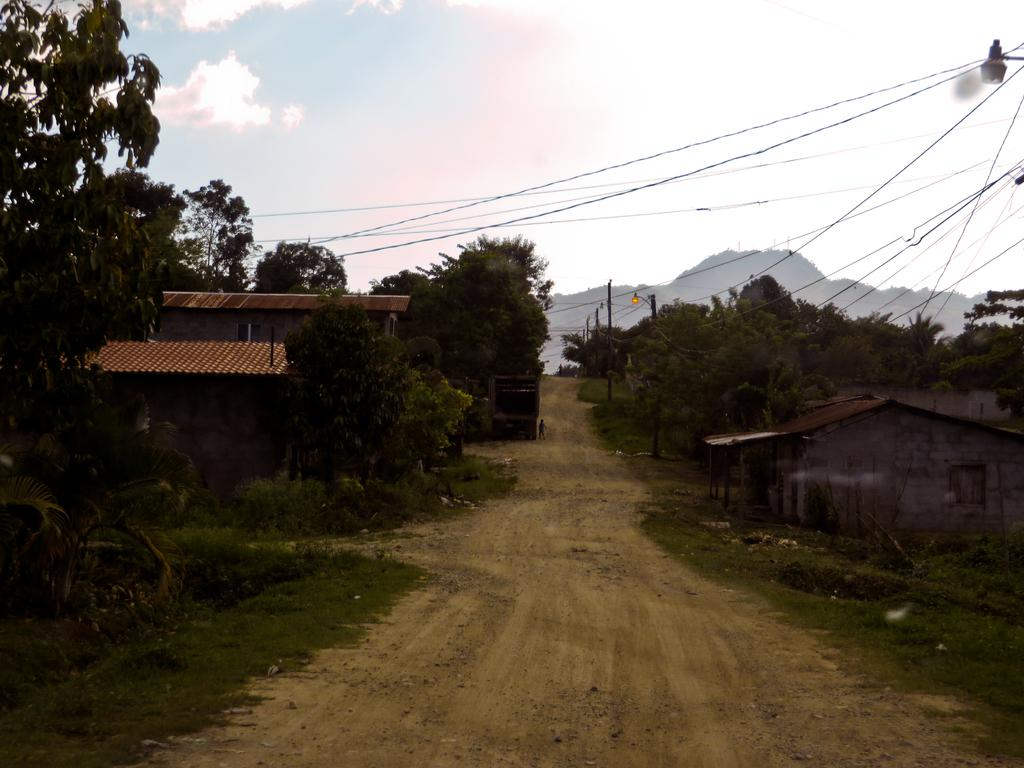What is the main feature in the center of the image? There is a dirt road in the center of the image. What can be seen on either side of the dirt road? There are trees and houses on either side of the dirt road. What else is visible in the image? There are wires visible in the image. What can be seen in the background of the image? There are mountains in the background of the image. What type of silver table can be seen in the image? There is no silver table present in the image. What beliefs are represented by the houses in the image? The image does not convey any specific beliefs; it simply shows houses on either side of the dirt road. 